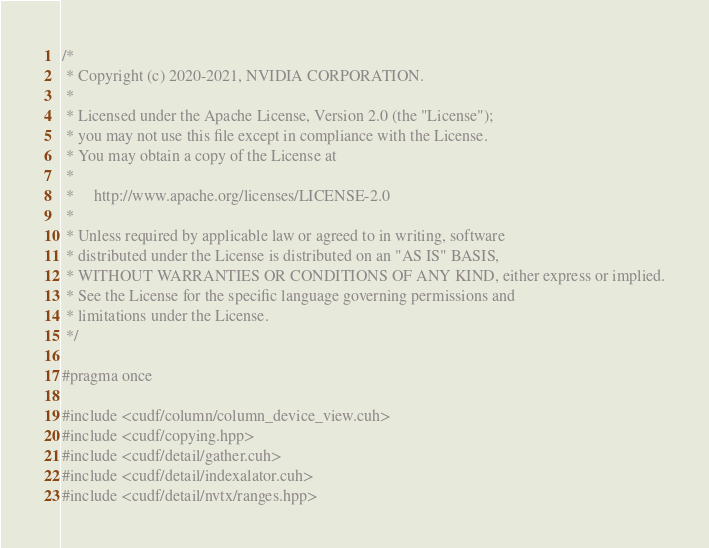<code> <loc_0><loc_0><loc_500><loc_500><_Cuda_>/*
 * Copyright (c) 2020-2021, NVIDIA CORPORATION.
 *
 * Licensed under the Apache License, Version 2.0 (the "License");
 * you may not use this file except in compliance with the License.
 * You may obtain a copy of the License at
 *
 *     http://www.apache.org/licenses/LICENSE-2.0
 *
 * Unless required by applicable law or agreed to in writing, software
 * distributed under the License is distributed on an "AS IS" BASIS,
 * WITHOUT WARRANTIES OR CONDITIONS OF ANY KIND, either express or implied.
 * See the License for the specific language governing permissions and
 * limitations under the License.
 */

#pragma once

#include <cudf/column/column_device_view.cuh>
#include <cudf/copying.hpp>
#include <cudf/detail/gather.cuh>
#include <cudf/detail/indexalator.cuh>
#include <cudf/detail/nvtx/ranges.hpp></code> 